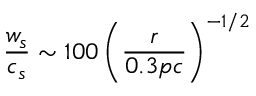<formula> <loc_0><loc_0><loc_500><loc_500>\frac { w _ { s } } { c _ { s } } \sim 1 0 0 \left ( \frac { r } { 0 . 3 p c } \right ) ^ { - 1 / 2 }</formula> 